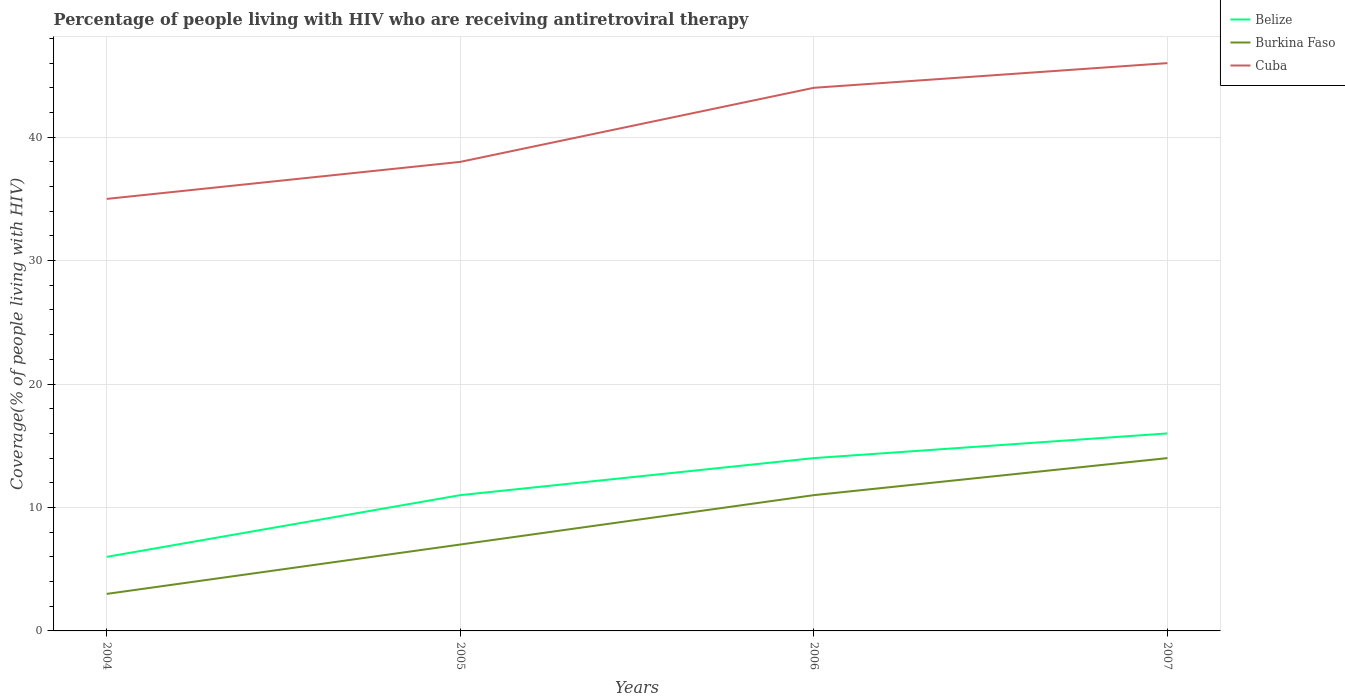How many different coloured lines are there?
Offer a terse response. 3. Across all years, what is the maximum percentage of the HIV infected people who are receiving antiretroviral therapy in Cuba?
Your response must be concise. 35. In which year was the percentage of the HIV infected people who are receiving antiretroviral therapy in Belize maximum?
Your answer should be compact. 2004. What is the total percentage of the HIV infected people who are receiving antiretroviral therapy in Cuba in the graph?
Provide a succinct answer. -11. What is the difference between the highest and the second highest percentage of the HIV infected people who are receiving antiretroviral therapy in Cuba?
Give a very brief answer. 11. Is the percentage of the HIV infected people who are receiving antiretroviral therapy in Belize strictly greater than the percentage of the HIV infected people who are receiving antiretroviral therapy in Burkina Faso over the years?
Ensure brevity in your answer.  No. How many lines are there?
Offer a very short reply. 3. What is the difference between two consecutive major ticks on the Y-axis?
Your response must be concise. 10. How many legend labels are there?
Your answer should be compact. 3. What is the title of the graph?
Give a very brief answer. Percentage of people living with HIV who are receiving antiretroviral therapy. Does "Azerbaijan" appear as one of the legend labels in the graph?
Ensure brevity in your answer.  No. What is the label or title of the X-axis?
Give a very brief answer. Years. What is the label or title of the Y-axis?
Make the answer very short. Coverage(% of people living with HIV). What is the Coverage(% of people living with HIV) of Belize in 2004?
Keep it short and to the point. 6. What is the Coverage(% of people living with HIV) in Burkina Faso in 2004?
Your answer should be compact. 3. What is the Coverage(% of people living with HIV) in Belize in 2005?
Provide a succinct answer. 11. What is the Coverage(% of people living with HIV) of Cuba in 2005?
Ensure brevity in your answer.  38. What is the Coverage(% of people living with HIV) of Belize in 2006?
Ensure brevity in your answer.  14. What is the Coverage(% of people living with HIV) in Cuba in 2007?
Offer a terse response. 46. Across all years, what is the maximum Coverage(% of people living with HIV) of Belize?
Your answer should be very brief. 16. Across all years, what is the maximum Coverage(% of people living with HIV) of Burkina Faso?
Provide a succinct answer. 14. Across all years, what is the maximum Coverage(% of people living with HIV) of Cuba?
Keep it short and to the point. 46. Across all years, what is the minimum Coverage(% of people living with HIV) in Belize?
Ensure brevity in your answer.  6. Across all years, what is the minimum Coverage(% of people living with HIV) of Cuba?
Give a very brief answer. 35. What is the total Coverage(% of people living with HIV) in Belize in the graph?
Offer a very short reply. 47. What is the total Coverage(% of people living with HIV) in Cuba in the graph?
Provide a succinct answer. 163. What is the difference between the Coverage(% of people living with HIV) in Belize in 2004 and that in 2005?
Your answer should be very brief. -5. What is the difference between the Coverage(% of people living with HIV) of Burkina Faso in 2004 and that in 2006?
Keep it short and to the point. -8. What is the difference between the Coverage(% of people living with HIV) of Belize in 2004 and that in 2007?
Make the answer very short. -10. What is the difference between the Coverage(% of people living with HIV) in Burkina Faso in 2004 and that in 2007?
Your answer should be very brief. -11. What is the difference between the Coverage(% of people living with HIV) in Belize in 2005 and that in 2006?
Ensure brevity in your answer.  -3. What is the difference between the Coverage(% of people living with HIV) in Burkina Faso in 2005 and that in 2006?
Your answer should be compact. -4. What is the difference between the Coverage(% of people living with HIV) of Burkina Faso in 2006 and that in 2007?
Offer a terse response. -3. What is the difference between the Coverage(% of people living with HIV) of Cuba in 2006 and that in 2007?
Your answer should be very brief. -2. What is the difference between the Coverage(% of people living with HIV) in Belize in 2004 and the Coverage(% of people living with HIV) in Burkina Faso in 2005?
Offer a very short reply. -1. What is the difference between the Coverage(% of people living with HIV) in Belize in 2004 and the Coverage(% of people living with HIV) in Cuba in 2005?
Your response must be concise. -32. What is the difference between the Coverage(% of people living with HIV) of Burkina Faso in 2004 and the Coverage(% of people living with HIV) of Cuba in 2005?
Provide a short and direct response. -35. What is the difference between the Coverage(% of people living with HIV) of Belize in 2004 and the Coverage(% of people living with HIV) of Cuba in 2006?
Offer a terse response. -38. What is the difference between the Coverage(% of people living with HIV) in Burkina Faso in 2004 and the Coverage(% of people living with HIV) in Cuba in 2006?
Ensure brevity in your answer.  -41. What is the difference between the Coverage(% of people living with HIV) in Belize in 2004 and the Coverage(% of people living with HIV) in Cuba in 2007?
Your answer should be compact. -40. What is the difference between the Coverage(% of people living with HIV) of Burkina Faso in 2004 and the Coverage(% of people living with HIV) of Cuba in 2007?
Ensure brevity in your answer.  -43. What is the difference between the Coverage(% of people living with HIV) of Belize in 2005 and the Coverage(% of people living with HIV) of Burkina Faso in 2006?
Give a very brief answer. 0. What is the difference between the Coverage(% of people living with HIV) of Belize in 2005 and the Coverage(% of people living with HIV) of Cuba in 2006?
Make the answer very short. -33. What is the difference between the Coverage(% of people living with HIV) in Burkina Faso in 2005 and the Coverage(% of people living with HIV) in Cuba in 2006?
Make the answer very short. -37. What is the difference between the Coverage(% of people living with HIV) in Belize in 2005 and the Coverage(% of people living with HIV) in Burkina Faso in 2007?
Make the answer very short. -3. What is the difference between the Coverage(% of people living with HIV) of Belize in 2005 and the Coverage(% of people living with HIV) of Cuba in 2007?
Offer a terse response. -35. What is the difference between the Coverage(% of people living with HIV) in Burkina Faso in 2005 and the Coverage(% of people living with HIV) in Cuba in 2007?
Ensure brevity in your answer.  -39. What is the difference between the Coverage(% of people living with HIV) of Belize in 2006 and the Coverage(% of people living with HIV) of Cuba in 2007?
Offer a very short reply. -32. What is the difference between the Coverage(% of people living with HIV) of Burkina Faso in 2006 and the Coverage(% of people living with HIV) of Cuba in 2007?
Make the answer very short. -35. What is the average Coverage(% of people living with HIV) of Belize per year?
Provide a short and direct response. 11.75. What is the average Coverage(% of people living with HIV) of Burkina Faso per year?
Provide a short and direct response. 8.75. What is the average Coverage(% of people living with HIV) in Cuba per year?
Provide a succinct answer. 40.75. In the year 2004, what is the difference between the Coverage(% of people living with HIV) in Belize and Coverage(% of people living with HIV) in Cuba?
Provide a succinct answer. -29. In the year 2004, what is the difference between the Coverage(% of people living with HIV) of Burkina Faso and Coverage(% of people living with HIV) of Cuba?
Offer a very short reply. -32. In the year 2005, what is the difference between the Coverage(% of people living with HIV) in Belize and Coverage(% of people living with HIV) in Burkina Faso?
Give a very brief answer. 4. In the year 2005, what is the difference between the Coverage(% of people living with HIV) in Burkina Faso and Coverage(% of people living with HIV) in Cuba?
Provide a succinct answer. -31. In the year 2006, what is the difference between the Coverage(% of people living with HIV) of Belize and Coverage(% of people living with HIV) of Cuba?
Provide a succinct answer. -30. In the year 2006, what is the difference between the Coverage(% of people living with HIV) of Burkina Faso and Coverage(% of people living with HIV) of Cuba?
Your response must be concise. -33. In the year 2007, what is the difference between the Coverage(% of people living with HIV) in Belize and Coverage(% of people living with HIV) in Cuba?
Your answer should be very brief. -30. In the year 2007, what is the difference between the Coverage(% of people living with HIV) of Burkina Faso and Coverage(% of people living with HIV) of Cuba?
Your answer should be compact. -32. What is the ratio of the Coverage(% of people living with HIV) in Belize in 2004 to that in 2005?
Your response must be concise. 0.55. What is the ratio of the Coverage(% of people living with HIV) of Burkina Faso in 2004 to that in 2005?
Your answer should be very brief. 0.43. What is the ratio of the Coverage(% of people living with HIV) of Cuba in 2004 to that in 2005?
Offer a terse response. 0.92. What is the ratio of the Coverage(% of people living with HIV) in Belize in 2004 to that in 2006?
Your answer should be compact. 0.43. What is the ratio of the Coverage(% of people living with HIV) in Burkina Faso in 2004 to that in 2006?
Provide a succinct answer. 0.27. What is the ratio of the Coverage(% of people living with HIV) of Cuba in 2004 to that in 2006?
Your answer should be very brief. 0.8. What is the ratio of the Coverage(% of people living with HIV) of Belize in 2004 to that in 2007?
Offer a terse response. 0.38. What is the ratio of the Coverage(% of people living with HIV) of Burkina Faso in 2004 to that in 2007?
Keep it short and to the point. 0.21. What is the ratio of the Coverage(% of people living with HIV) of Cuba in 2004 to that in 2007?
Offer a terse response. 0.76. What is the ratio of the Coverage(% of people living with HIV) in Belize in 2005 to that in 2006?
Make the answer very short. 0.79. What is the ratio of the Coverage(% of people living with HIV) in Burkina Faso in 2005 to that in 2006?
Give a very brief answer. 0.64. What is the ratio of the Coverage(% of people living with HIV) in Cuba in 2005 to that in 2006?
Give a very brief answer. 0.86. What is the ratio of the Coverage(% of people living with HIV) in Belize in 2005 to that in 2007?
Provide a short and direct response. 0.69. What is the ratio of the Coverage(% of people living with HIV) of Burkina Faso in 2005 to that in 2007?
Offer a very short reply. 0.5. What is the ratio of the Coverage(% of people living with HIV) of Cuba in 2005 to that in 2007?
Keep it short and to the point. 0.83. What is the ratio of the Coverage(% of people living with HIV) of Belize in 2006 to that in 2007?
Provide a succinct answer. 0.88. What is the ratio of the Coverage(% of people living with HIV) in Burkina Faso in 2006 to that in 2007?
Ensure brevity in your answer.  0.79. What is the ratio of the Coverage(% of people living with HIV) of Cuba in 2006 to that in 2007?
Give a very brief answer. 0.96. What is the difference between the highest and the second highest Coverage(% of people living with HIV) in Belize?
Keep it short and to the point. 2. What is the difference between the highest and the second highest Coverage(% of people living with HIV) of Burkina Faso?
Keep it short and to the point. 3. What is the difference between the highest and the second highest Coverage(% of people living with HIV) of Cuba?
Provide a short and direct response. 2. What is the difference between the highest and the lowest Coverage(% of people living with HIV) of Burkina Faso?
Provide a short and direct response. 11. 